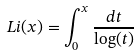<formula> <loc_0><loc_0><loc_500><loc_500>L i ( x ) = \int _ { 0 } ^ { x } \frac { d t } { \log ( t ) }</formula> 